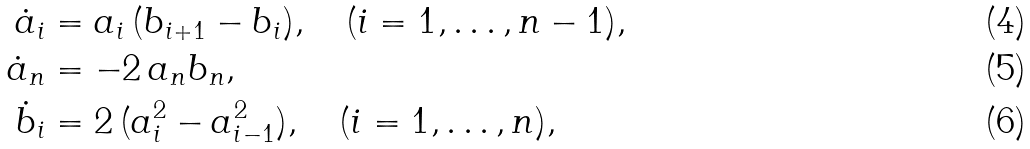<formula> <loc_0><loc_0><loc_500><loc_500>\dot { a } _ { i } & = a _ { i } \, ( b _ { i + 1 } - b _ { i } ) , \quad ( i = 1 , \dots , n - 1 ) , \\ \dot { a } _ { n } & = - 2 \, a _ { n } b _ { n } , \\ \dot { b } _ { i } & = 2 \, ( a _ { i } ^ { 2 } - a _ { i - 1 } ^ { 2 } ) , \quad ( i = 1 , \dots , n ) ,</formula> 